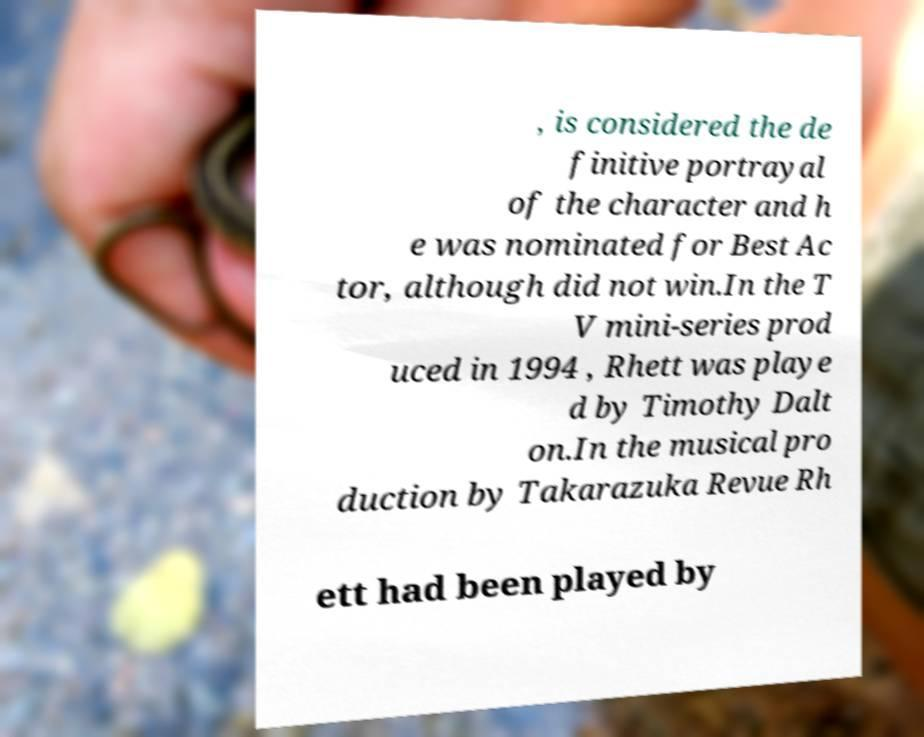Please identify and transcribe the text found in this image. , is considered the de finitive portrayal of the character and h e was nominated for Best Ac tor, although did not win.In the T V mini-series prod uced in 1994 , Rhett was playe d by Timothy Dalt on.In the musical pro duction by Takarazuka Revue Rh ett had been played by 